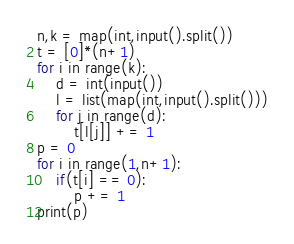<code> <loc_0><loc_0><loc_500><loc_500><_Python_>n,k = map(int,input().split())
t = [0]*(n+1)
for i in range(k):
    d = int(input())
    l = list(map(int,input().split()))
    for j in range(d):
        t[l[j]] += 1
p = 0
for i in range(1,n+1):
    if(t[i] == 0):
        p += 1
print(p)</code> 